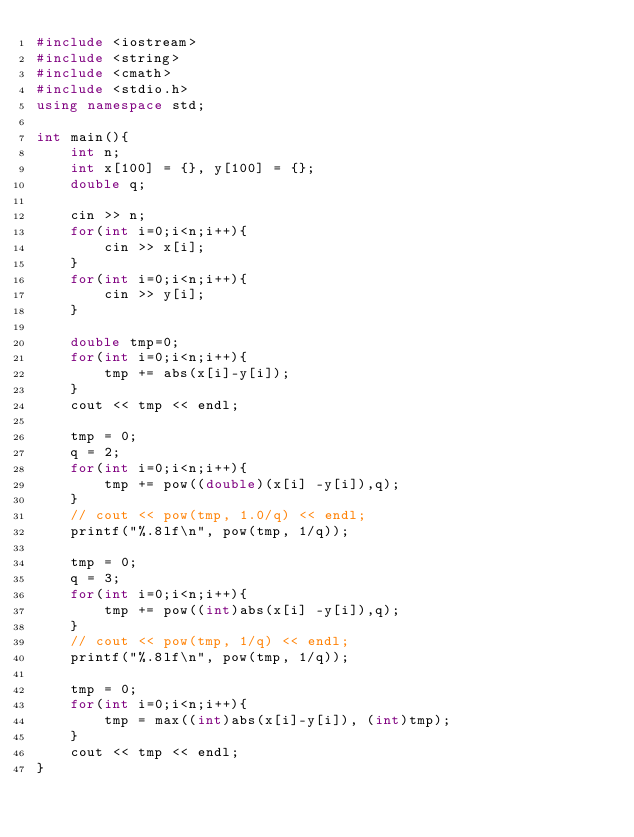<code> <loc_0><loc_0><loc_500><loc_500><_C++_>#include <iostream>
#include <string>
#include <cmath>
#include <stdio.h>
using namespace std;
 
int main(){
    int n;
    int x[100] = {}, y[100] = {};
    double q;

    cin >> n;
    for(int i=0;i<n;i++){
        cin >> x[i];
    }
    for(int i=0;i<n;i++){
        cin >> y[i];
    }

    double tmp=0;
    for(int i=0;i<n;i++){
        tmp += abs(x[i]-y[i]);
    }
    cout << tmp << endl;

    tmp = 0;
    q = 2;
    for(int i=0;i<n;i++){
        tmp += pow((double)(x[i] -y[i]),q);
    }
    // cout << pow(tmp, 1.0/q) << endl;
    printf("%.8lf\n", pow(tmp, 1/q));

    tmp = 0;
    q = 3;
    for(int i=0;i<n;i++){
        tmp += pow((int)abs(x[i] -y[i]),q);
    }
    // cout << pow(tmp, 1/q) << endl;
    printf("%.8lf\n", pow(tmp, 1/q));

    tmp = 0;
    for(int i=0;i<n;i++){
        tmp = max((int)abs(x[i]-y[i]), (int)tmp);
    }
    cout << tmp << endl;
}
</code> 